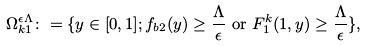Convert formula to latex. <formula><loc_0><loc_0><loc_500><loc_500>& \Omega ^ { \epsilon \Lambda } _ { k 1 } \colon = \{ y \in [ 0 , 1 ] ; f _ { b 2 } ( y ) \geq \frac { \Lambda } { \epsilon } \text {  or  } F ^ { k } _ { 1 } ( 1 , y ) \geq \frac { \Lambda } { \epsilon } \} ,</formula> 